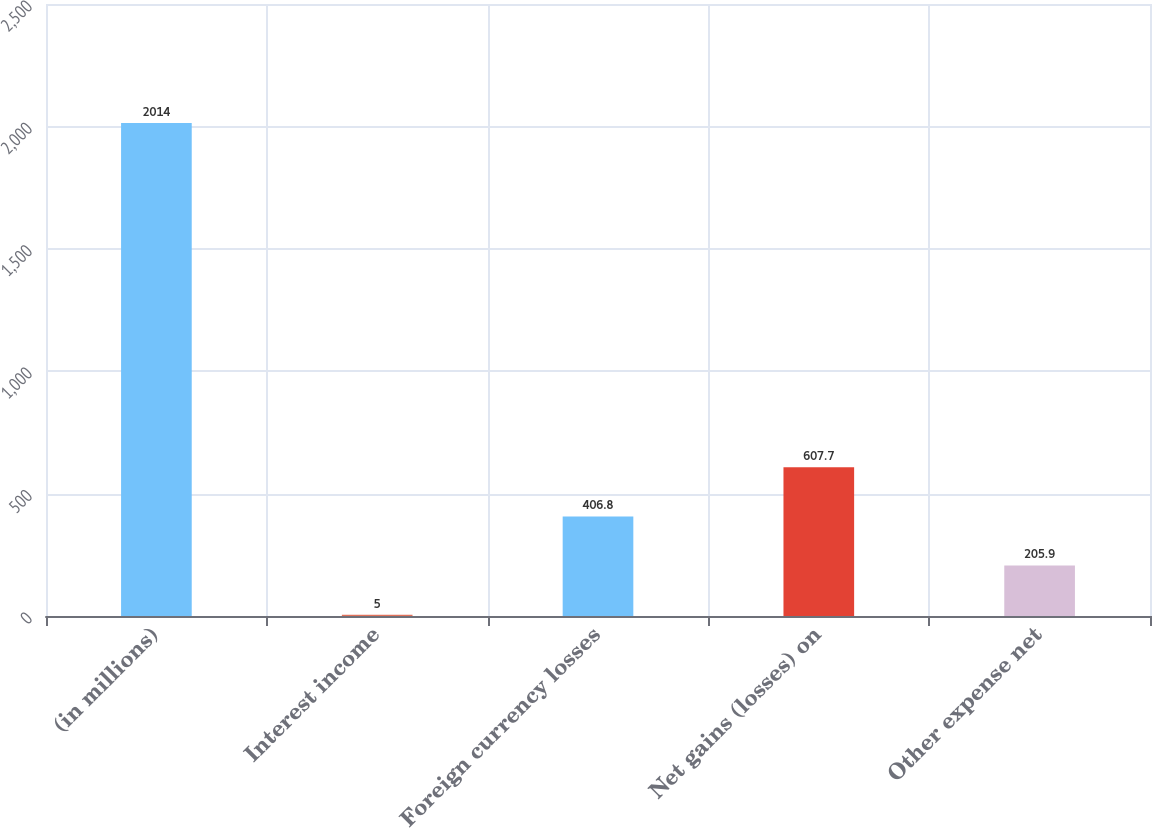<chart> <loc_0><loc_0><loc_500><loc_500><bar_chart><fcel>(in millions)<fcel>Interest income<fcel>Foreign currency losses<fcel>Net gains (losses) on<fcel>Other expense net<nl><fcel>2014<fcel>5<fcel>406.8<fcel>607.7<fcel>205.9<nl></chart> 